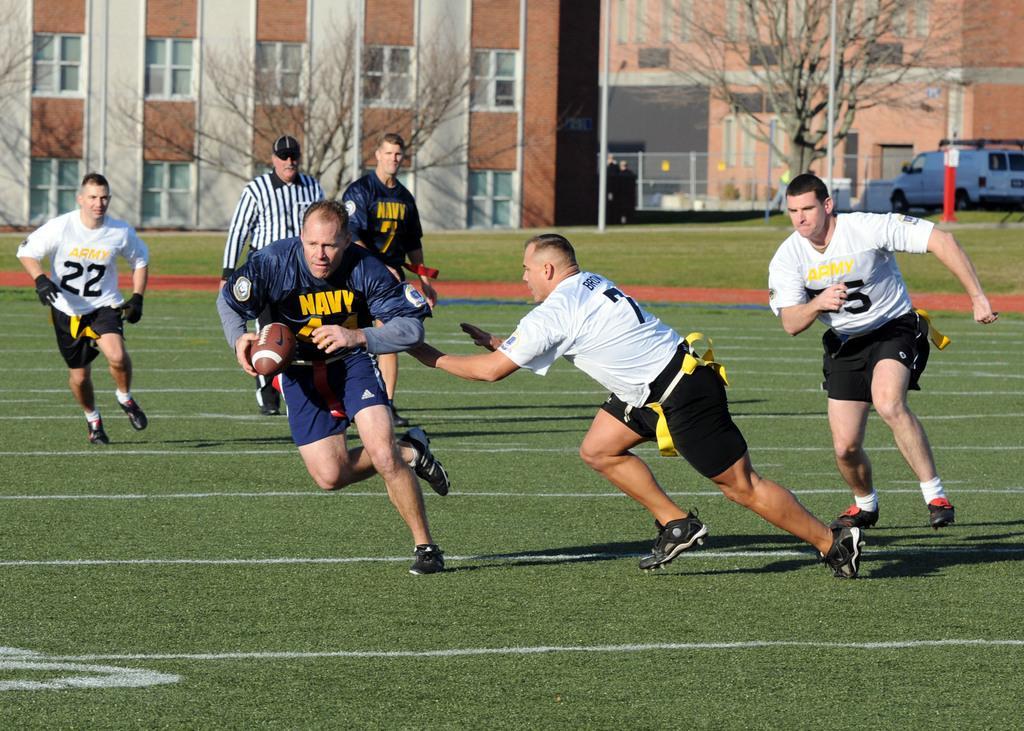How would you summarize this image in a sentence or two? In this picture there are three people running and there is a man holding the ball and he is running and there are two people walking. At the back there are buildings and trees and there is a vehicle and there is an object. At the bottom there is grass. 